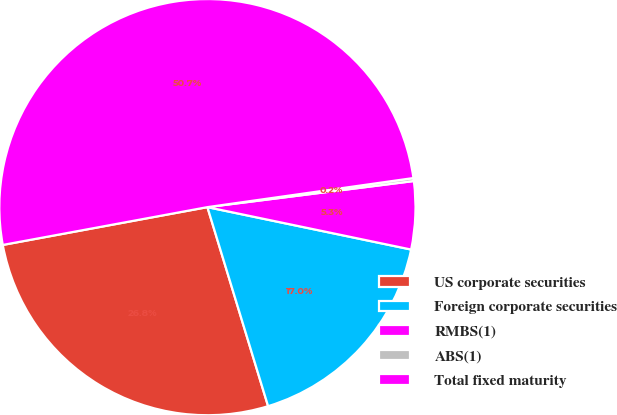Convert chart. <chart><loc_0><loc_0><loc_500><loc_500><pie_chart><fcel>US corporate securities<fcel>Foreign corporate securities<fcel>RMBS(1)<fcel>ABS(1)<fcel>Total fixed maturity<nl><fcel>26.8%<fcel>17.02%<fcel>5.27%<fcel>0.23%<fcel>50.67%<nl></chart> 